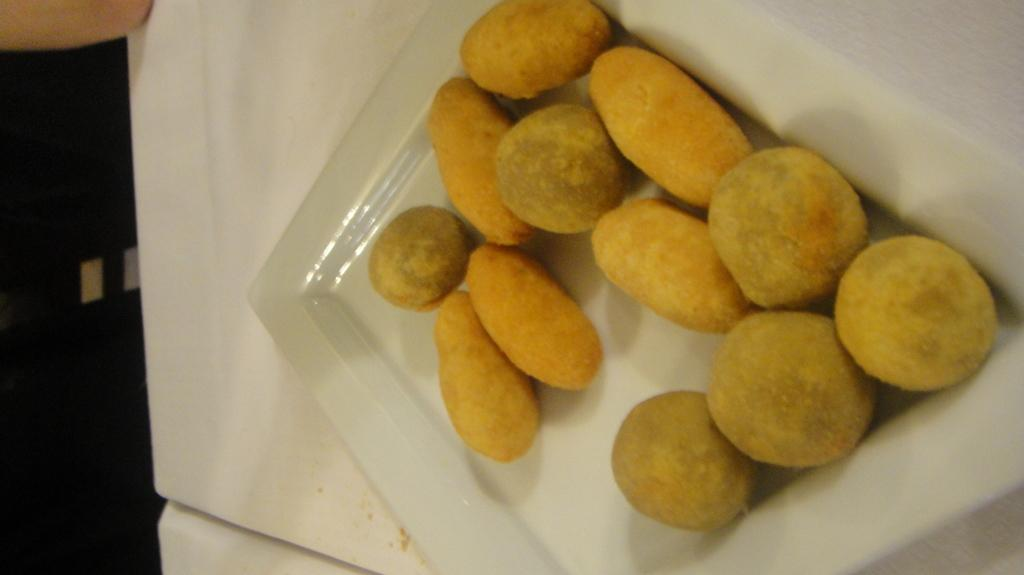What is on the glass plate in the image? There are food items on a glass plate in the image. Where is the glass plate located? The glass plate is kept on a table. How many buildings are visible in the downtown area in the image? There is no downtown area or buildings visible in the image; it only shows food items on a glass plate kept on a table. 